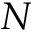Convert formula to latex. <formula><loc_0><loc_0><loc_500><loc_500>N</formula> 